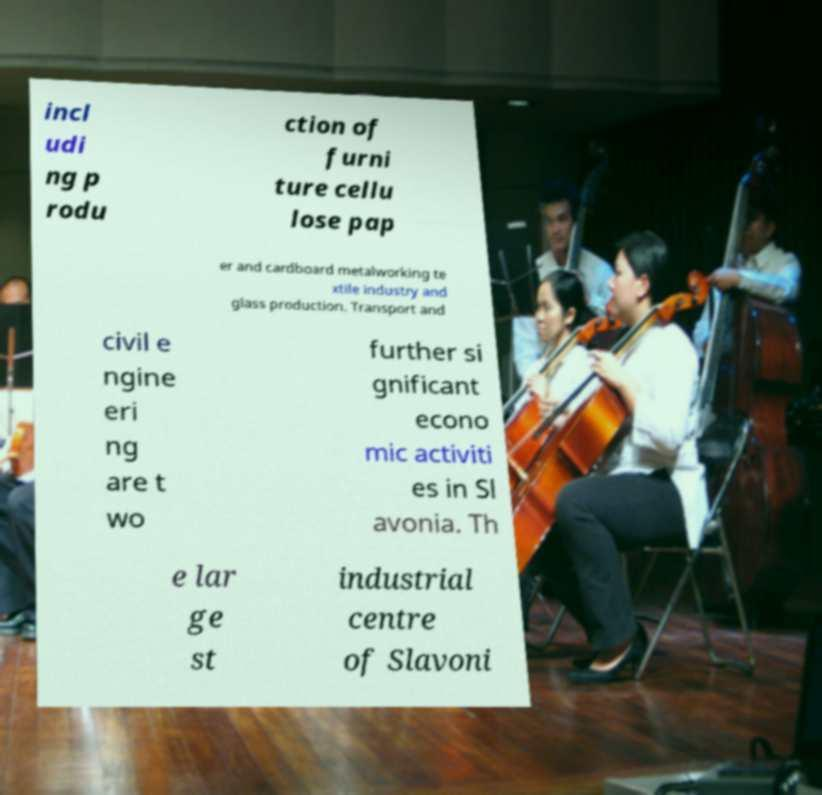There's text embedded in this image that I need extracted. Can you transcribe it verbatim? incl udi ng p rodu ction of furni ture cellu lose pap er and cardboard metalworking te xtile industry and glass production. Transport and civil e ngine eri ng are t wo further si gnificant econo mic activiti es in Sl avonia. Th e lar ge st industrial centre of Slavoni 